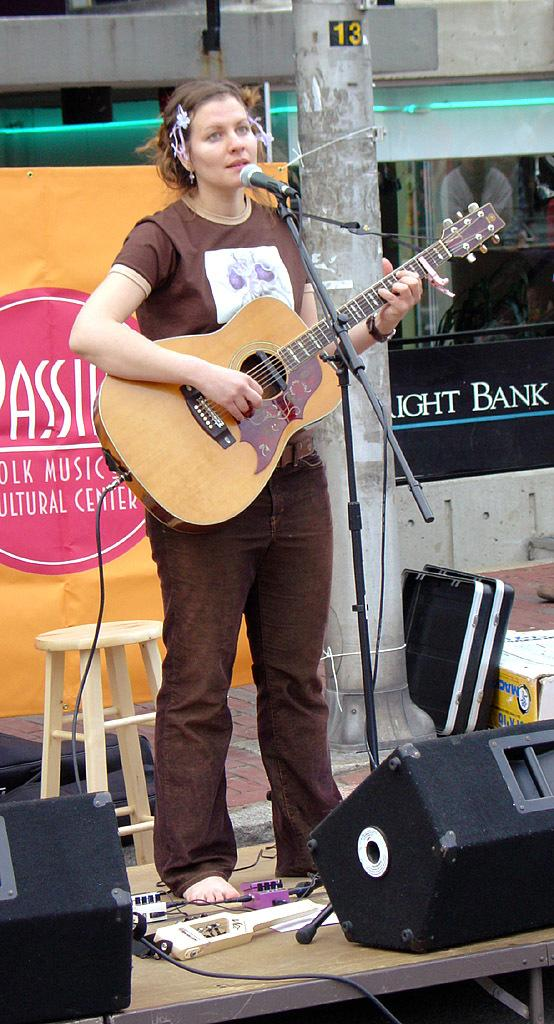Who is the main subject in the image? There is a woman in the image. What is the woman doing in the image? The woman is singing and playing the guitar. Where is the woman located in the image? The woman is on the floor. How does the woman stop the guitar from making noise in the image? The image does not show the woman stopping the guitar from making noise, as she is actively playing it. Additionally, there is no indication that the guitar is making noise in the image. 